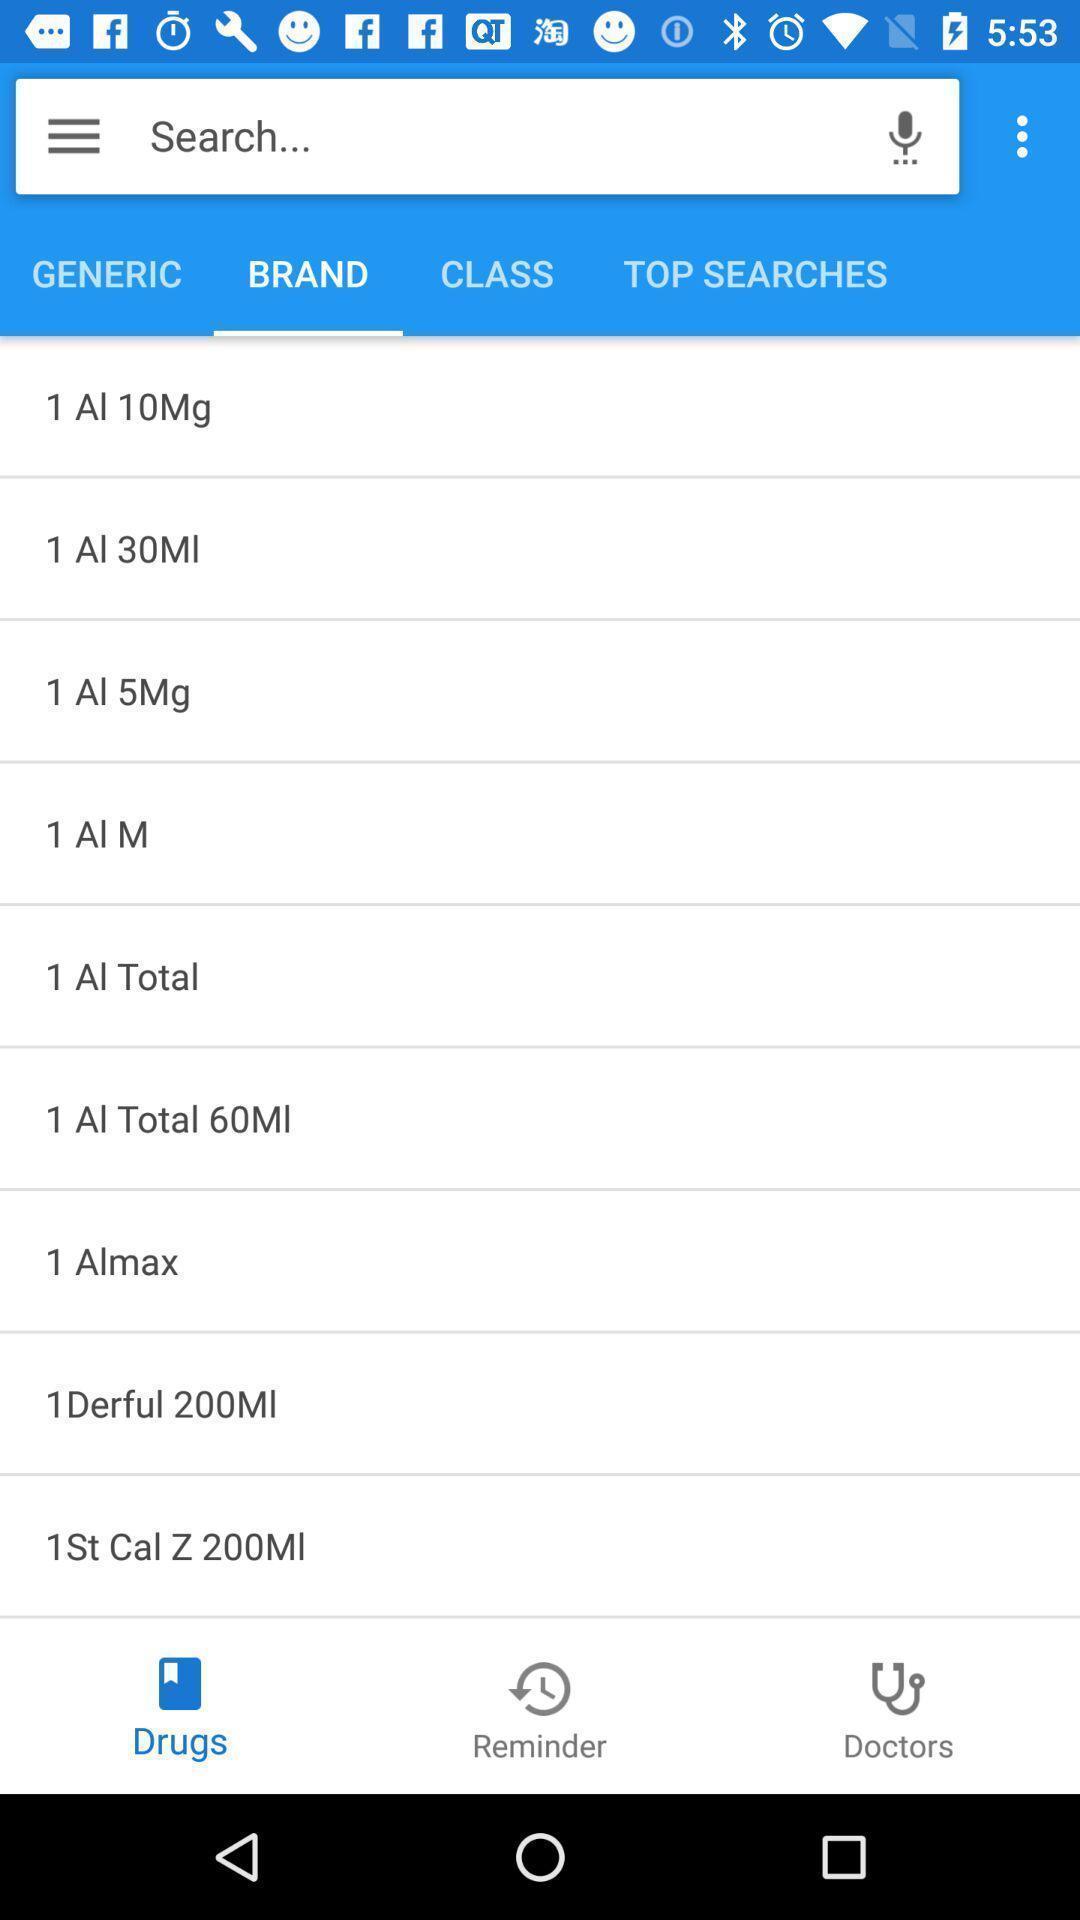Provide a textual representation of this image. Search page of a shopping app. 